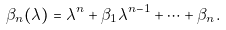Convert formula to latex. <formula><loc_0><loc_0><loc_500><loc_500>\beta _ { n } ( \lambda ) = \lambda ^ { n } + \beta _ { 1 } \lambda ^ { n - 1 } + \cdots + \beta _ { n } .</formula> 